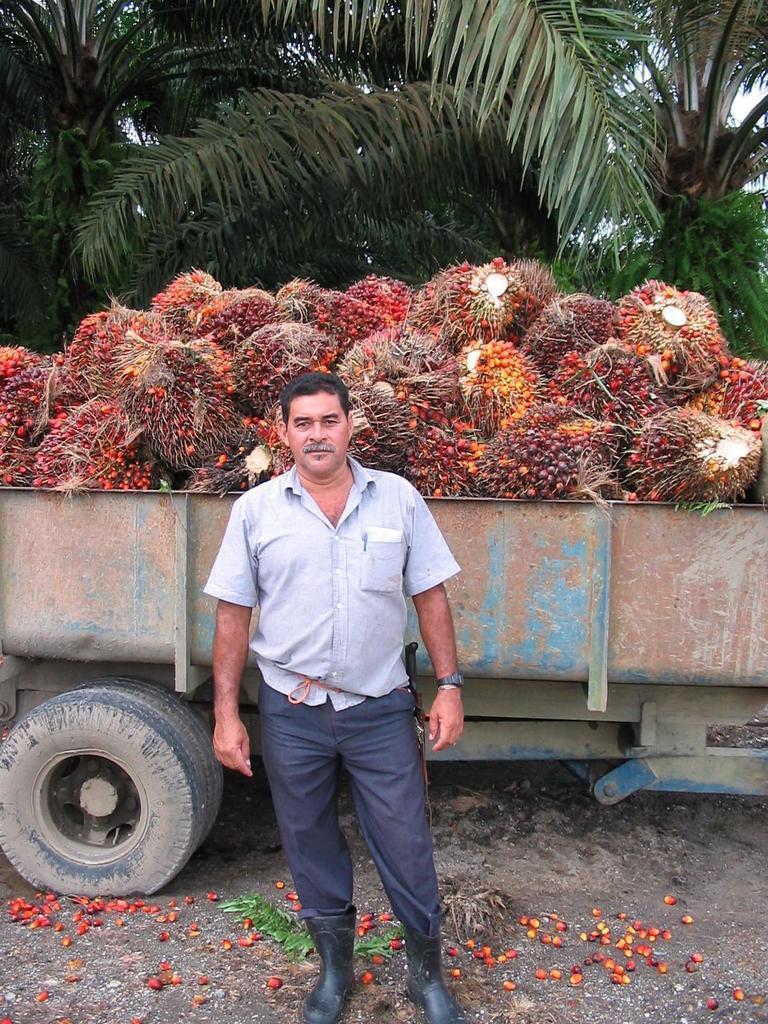Describe this image in one or two sentences. In this image I can see the person is standing. Back I can see few trees and few fruits in the vehicle. Fruits are in yellow, red and orange color. 